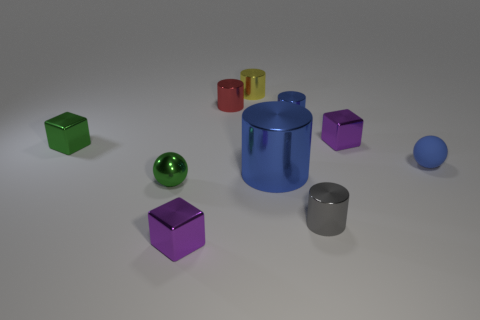Subtract all red cylinders. How many cylinders are left? 4 Subtract all big metal cylinders. How many cylinders are left? 4 Subtract all gray cylinders. Subtract all green balls. How many cylinders are left? 4 Subtract all spheres. How many objects are left? 8 Add 1 small matte things. How many small matte things are left? 2 Add 10 large purple rubber balls. How many large purple rubber balls exist? 10 Subtract 1 red cylinders. How many objects are left? 9 Subtract all red objects. Subtract all gray metallic cylinders. How many objects are left? 8 